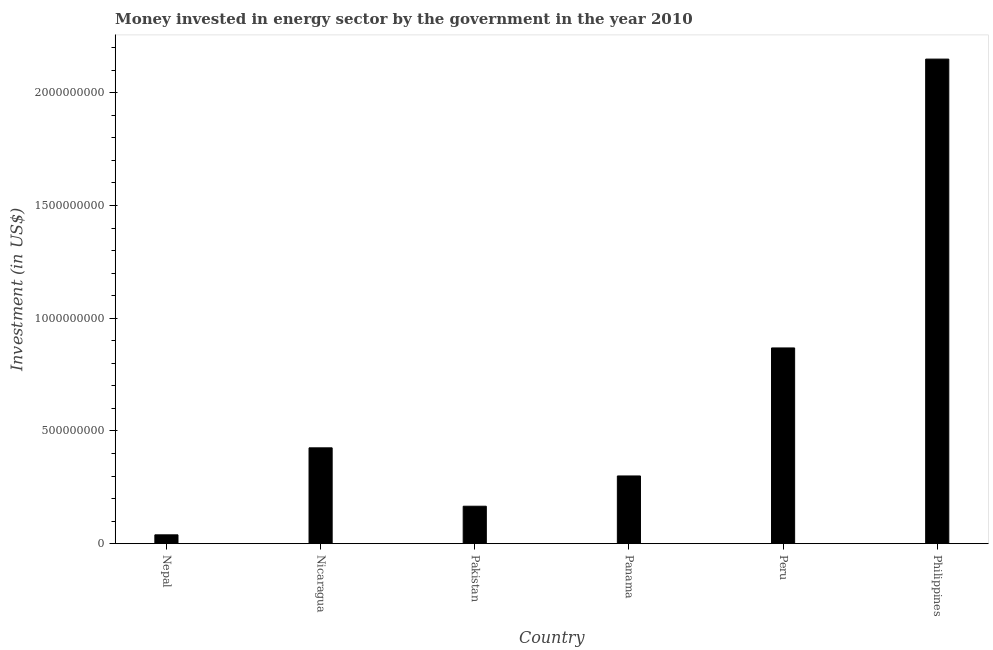Does the graph contain grids?
Keep it short and to the point. No. What is the title of the graph?
Your answer should be compact. Money invested in energy sector by the government in the year 2010. What is the label or title of the Y-axis?
Your answer should be compact. Investment (in US$). What is the investment in energy in Panama?
Give a very brief answer. 3.00e+08. Across all countries, what is the maximum investment in energy?
Your response must be concise. 2.15e+09. Across all countries, what is the minimum investment in energy?
Offer a terse response. 3.91e+07. In which country was the investment in energy minimum?
Offer a very short reply. Nepal. What is the sum of the investment in energy?
Offer a terse response. 3.95e+09. What is the difference between the investment in energy in Nicaragua and Panama?
Your response must be concise. 1.25e+08. What is the average investment in energy per country?
Your answer should be very brief. 6.58e+08. What is the median investment in energy?
Ensure brevity in your answer.  3.63e+08. What is the ratio of the investment in energy in Pakistan to that in Peru?
Provide a short and direct response. 0.19. Is the investment in energy in Nicaragua less than that in Philippines?
Your response must be concise. Yes. Is the difference between the investment in energy in Nicaragua and Panama greater than the difference between any two countries?
Offer a terse response. No. What is the difference between the highest and the second highest investment in energy?
Offer a very short reply. 1.28e+09. What is the difference between the highest and the lowest investment in energy?
Ensure brevity in your answer.  2.11e+09. In how many countries, is the investment in energy greater than the average investment in energy taken over all countries?
Give a very brief answer. 2. How many bars are there?
Ensure brevity in your answer.  6. How many countries are there in the graph?
Your response must be concise. 6. Are the values on the major ticks of Y-axis written in scientific E-notation?
Give a very brief answer. No. What is the Investment (in US$) in Nepal?
Your response must be concise. 3.91e+07. What is the Investment (in US$) in Nicaragua?
Your answer should be very brief. 4.25e+08. What is the Investment (in US$) in Pakistan?
Offer a terse response. 1.66e+08. What is the Investment (in US$) of Panama?
Your answer should be compact. 3.00e+08. What is the Investment (in US$) of Peru?
Ensure brevity in your answer.  8.68e+08. What is the Investment (in US$) of Philippines?
Offer a terse response. 2.15e+09. What is the difference between the Investment (in US$) in Nepal and Nicaragua?
Make the answer very short. -3.86e+08. What is the difference between the Investment (in US$) in Nepal and Pakistan?
Your answer should be compact. -1.27e+08. What is the difference between the Investment (in US$) in Nepal and Panama?
Keep it short and to the point. -2.61e+08. What is the difference between the Investment (in US$) in Nepal and Peru?
Your answer should be very brief. -8.29e+08. What is the difference between the Investment (in US$) in Nepal and Philippines?
Make the answer very short. -2.11e+09. What is the difference between the Investment (in US$) in Nicaragua and Pakistan?
Your answer should be compact. 2.59e+08. What is the difference between the Investment (in US$) in Nicaragua and Panama?
Ensure brevity in your answer.  1.25e+08. What is the difference between the Investment (in US$) in Nicaragua and Peru?
Keep it short and to the point. -4.43e+08. What is the difference between the Investment (in US$) in Nicaragua and Philippines?
Your answer should be compact. -1.72e+09. What is the difference between the Investment (in US$) in Pakistan and Panama?
Your response must be concise. -1.34e+08. What is the difference between the Investment (in US$) in Pakistan and Peru?
Provide a succinct answer. -7.02e+08. What is the difference between the Investment (in US$) in Pakistan and Philippines?
Give a very brief answer. -1.98e+09. What is the difference between the Investment (in US$) in Panama and Peru?
Your answer should be compact. -5.68e+08. What is the difference between the Investment (in US$) in Panama and Philippines?
Offer a very short reply. -1.85e+09. What is the difference between the Investment (in US$) in Peru and Philippines?
Provide a succinct answer. -1.28e+09. What is the ratio of the Investment (in US$) in Nepal to that in Nicaragua?
Give a very brief answer. 0.09. What is the ratio of the Investment (in US$) in Nepal to that in Pakistan?
Give a very brief answer. 0.24. What is the ratio of the Investment (in US$) in Nepal to that in Panama?
Keep it short and to the point. 0.13. What is the ratio of the Investment (in US$) in Nepal to that in Peru?
Give a very brief answer. 0.04. What is the ratio of the Investment (in US$) in Nepal to that in Philippines?
Your answer should be compact. 0.02. What is the ratio of the Investment (in US$) in Nicaragua to that in Pakistan?
Offer a very short reply. 2.56. What is the ratio of the Investment (in US$) in Nicaragua to that in Panama?
Provide a short and direct response. 1.42. What is the ratio of the Investment (in US$) in Nicaragua to that in Peru?
Provide a short and direct response. 0.49. What is the ratio of the Investment (in US$) in Nicaragua to that in Philippines?
Your answer should be compact. 0.2. What is the ratio of the Investment (in US$) in Pakistan to that in Panama?
Ensure brevity in your answer.  0.55. What is the ratio of the Investment (in US$) in Pakistan to that in Peru?
Keep it short and to the point. 0.19. What is the ratio of the Investment (in US$) in Pakistan to that in Philippines?
Ensure brevity in your answer.  0.08. What is the ratio of the Investment (in US$) in Panama to that in Peru?
Give a very brief answer. 0.35. What is the ratio of the Investment (in US$) in Panama to that in Philippines?
Keep it short and to the point. 0.14. What is the ratio of the Investment (in US$) in Peru to that in Philippines?
Offer a terse response. 0.4. 